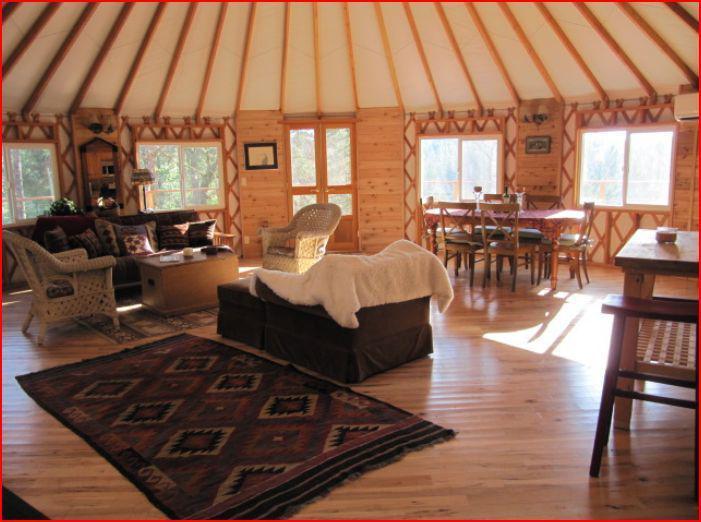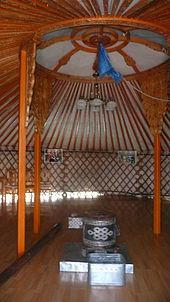The first image is the image on the left, the second image is the image on the right. Considering the images on both sides, is "In one image, at least four yurts are seen in an outdoor area with at least one tree, while a second image shows the interior of a yurt with lattice on wall area." valid? Answer yes or no. No. The first image is the image on the left, the second image is the image on the right. Analyze the images presented: Is the assertion "One image is an interior with lattice on the walls, and the other is an exterior shot of round buildings with a tall tree present." valid? Answer yes or no. No. 